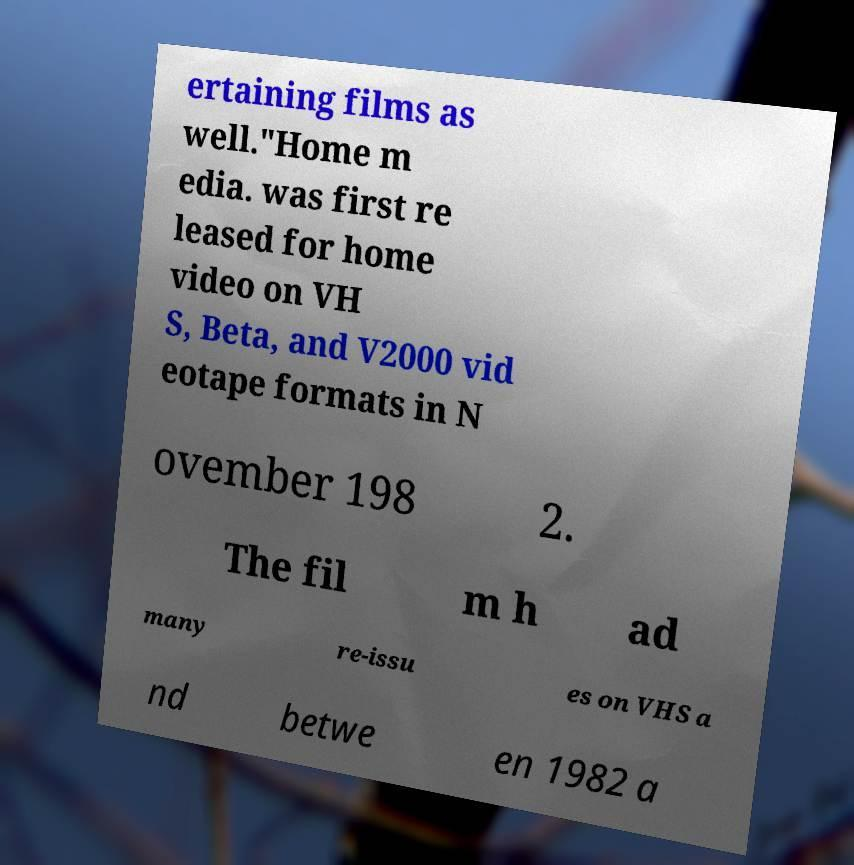Could you extract and type out the text from this image? ertaining films as well."Home m edia. was first re leased for home video on VH S, Beta, and V2000 vid eotape formats in N ovember 198 2. The fil m h ad many re-issu es on VHS a nd betwe en 1982 a 